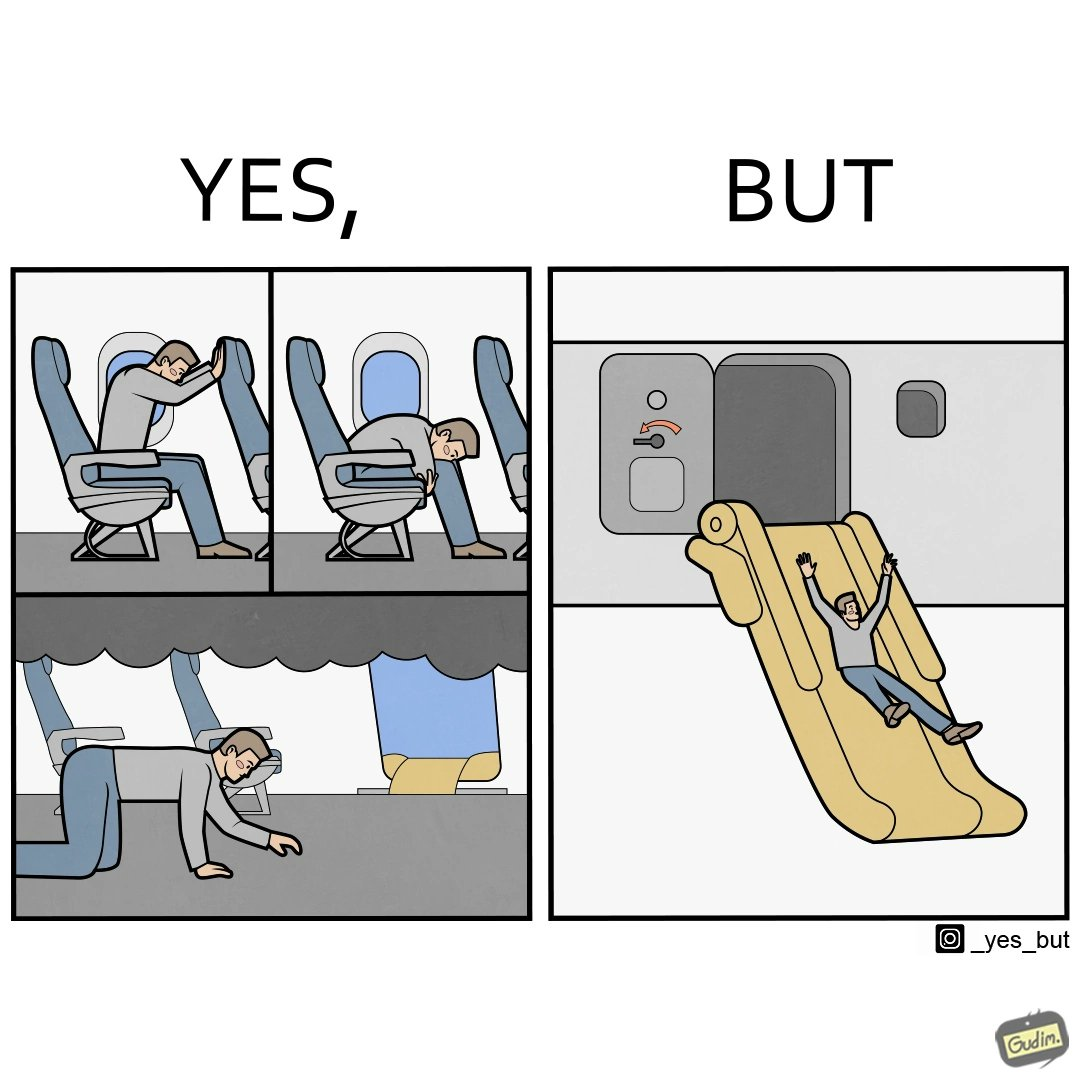What do you see in each half of this image? In the left part of the image: They are images of what one should do in an airplane in case of an imminent collision and fire In the right part of the image: It shows a man jumping out of an airplane in case of an emergency and using the emergency inflatable slides 